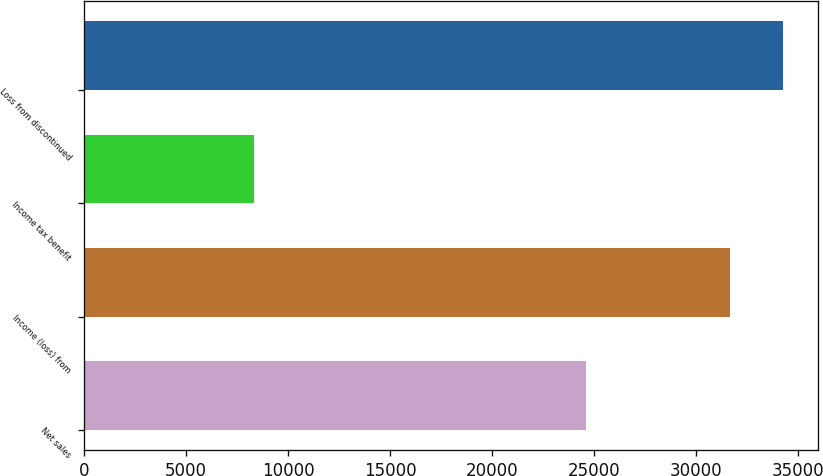Convert chart to OTSL. <chart><loc_0><loc_0><loc_500><loc_500><bar_chart><fcel>Net sales<fcel>Income (loss) from<fcel>Income tax benefit<fcel>Loss from discontinued<nl><fcel>24590<fcel>31654<fcel>8303.5<fcel>34248.5<nl></chart> 